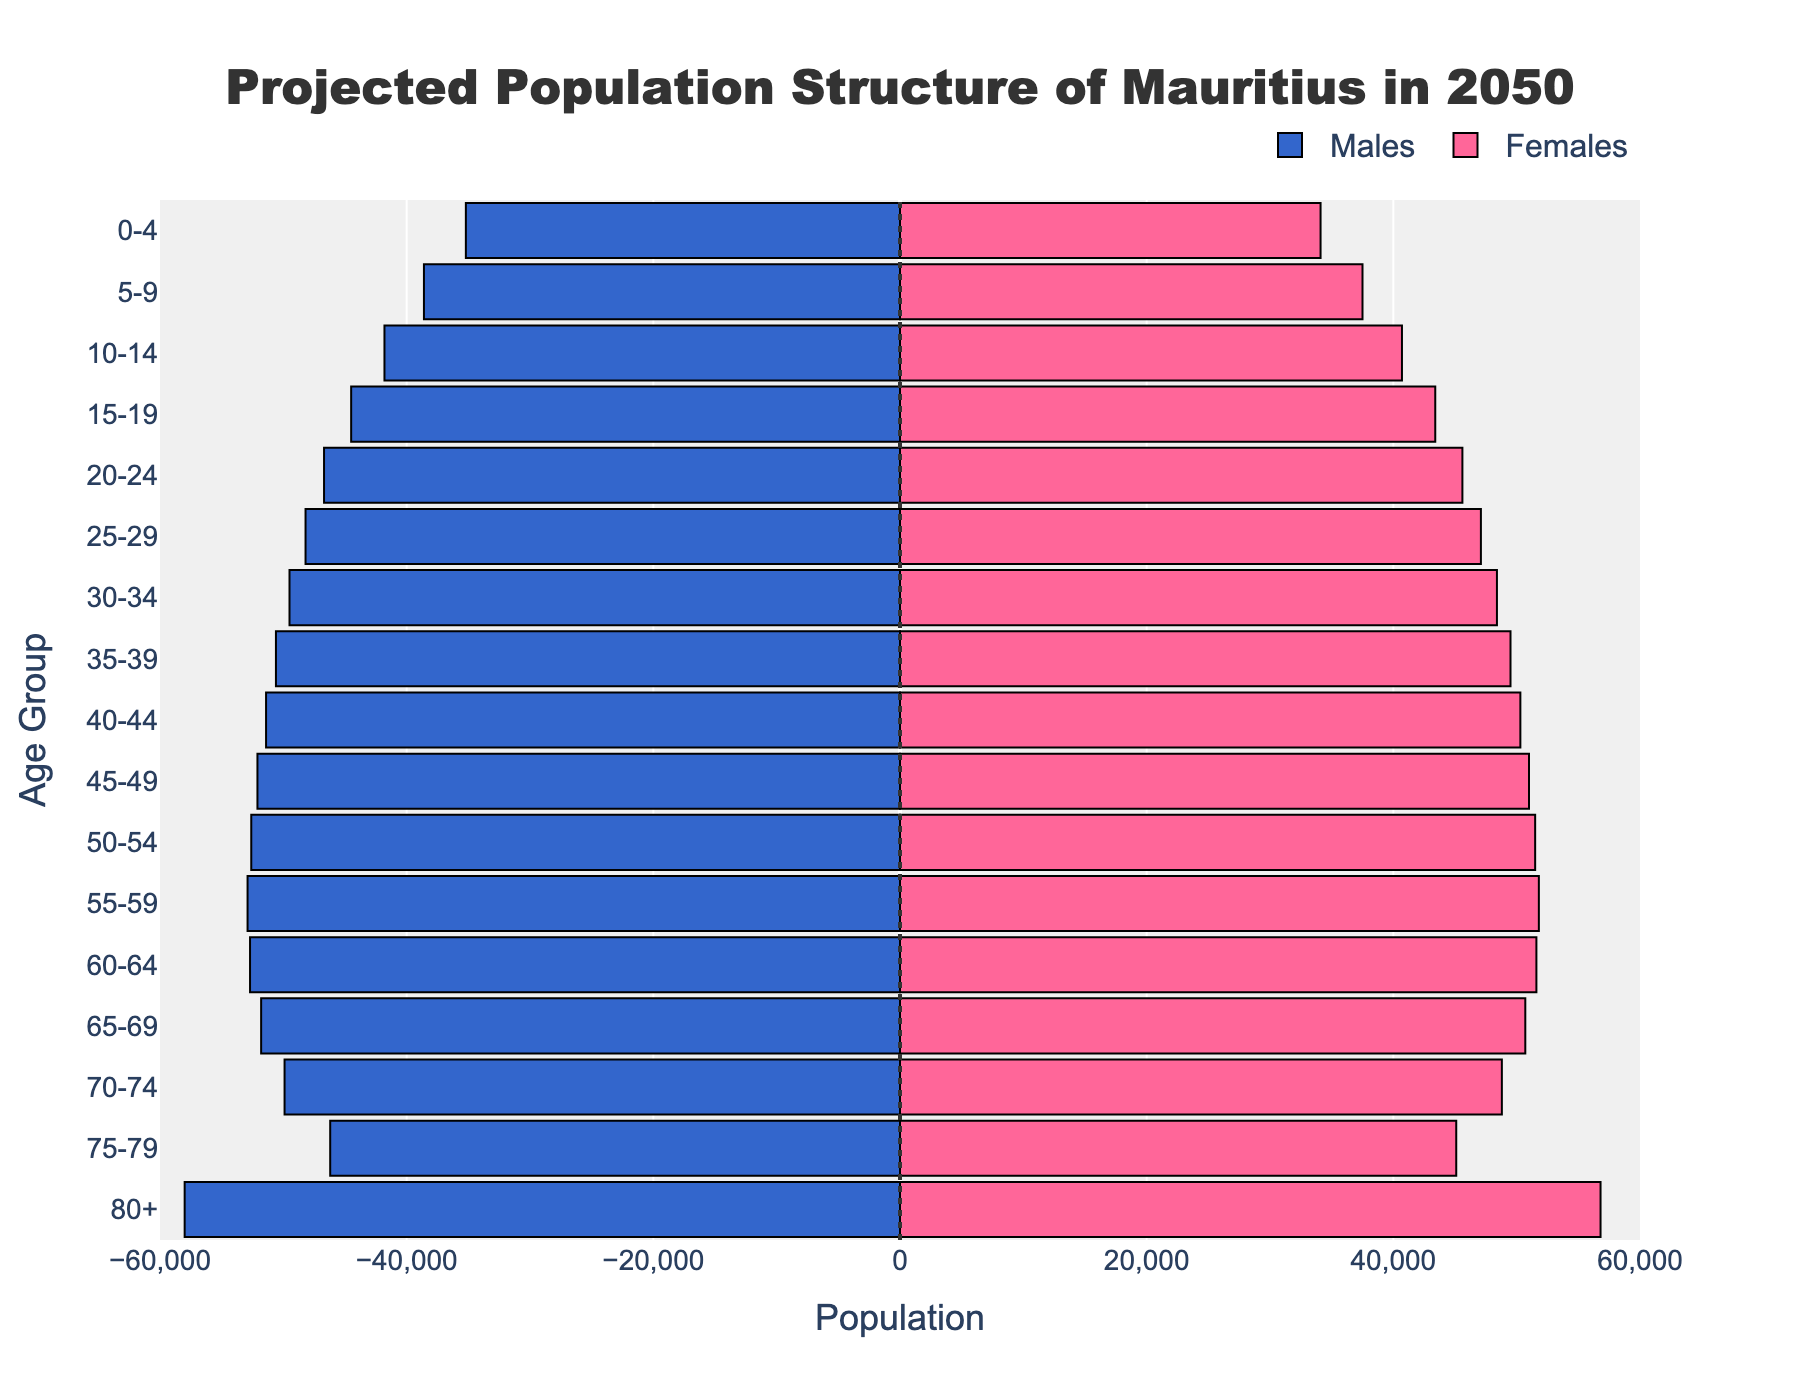What is the title of the figure? The title of the figure can be found at the top of the plot. It explains what the plot is about. The title reads, "Projected Population Structure of Mauritius in 2050."
Answer: Projected Population Structure of Mauritius in 2050 How many age groups are there in the population pyramid? The y-axis lists the age groups for which data is provided. By counting these distinct age groups, we can determine the total number shown. There are 17 age groups listed, from "0-4" to "80+."
Answer: 17 Which gender has a higher population in the age group 80+? By looking at the adjacent bars for the age group "80+," we can compare the lengths representing males and females. The bar for females extends further, indicating a larger population.
Answer: Females What is the population of males and females in the age group 30-34? To find these populations, locate the bars corresponding to the age group 30-34. The length of the bar for males is 49,500 and for females is 48,400.
Answer: Males: 49,500, Females: 48,400 In which age group is the male population closest to the female population? Comparisons are made between the lengths of the male and female bars within each age group to find the smallest difference. The age group with the closest populations is "65-69," with a minor gap (51,800 males and 50,700 females).
Answer: 65-69 Which age group has the largest difference between male and female populations? By examining all the age groups, the group with the most significant disparity between male and female bar lengths is identified. The group "80+" has a substantial difference: 58,000 males and 56,800 females, giving a difference of 1,200.
Answer: 80+ Calculate the total population for the age group 50-54. The total population for each age group is the sum of the populations of males and females. For the age group 50-54, adding 52,600 males and 51,500 females gives 104,100.
Answer: 104,100 Compare the population of males between the age groups 25-29 and 40-44, and state which is higher. By comparing the bar lengths of these age groups for males, it is seen that the population in the age group 40-44 (51,400) is higher than in the age group 25-29 (48,200).
Answer: 40-44 Based on the visual information, do you expect the population structure of Mauritius to be top-heavy or bottom-heavy in 2050? A top-heavy population is indicated by broader bars at higher age groups (older population). Observing the longer bars for older age groups like "80+" suggests that the projection is for a top-heavy structure.
Answer: Top-heavy What can be inferred about the life expectancy trend from this population pyramid? The presence of significantly higher populations in older age groups (especially "80+") implies that people are living longer. This suggests an improvement in life expectancy trends over time.
Answer: Increased life expectancy 